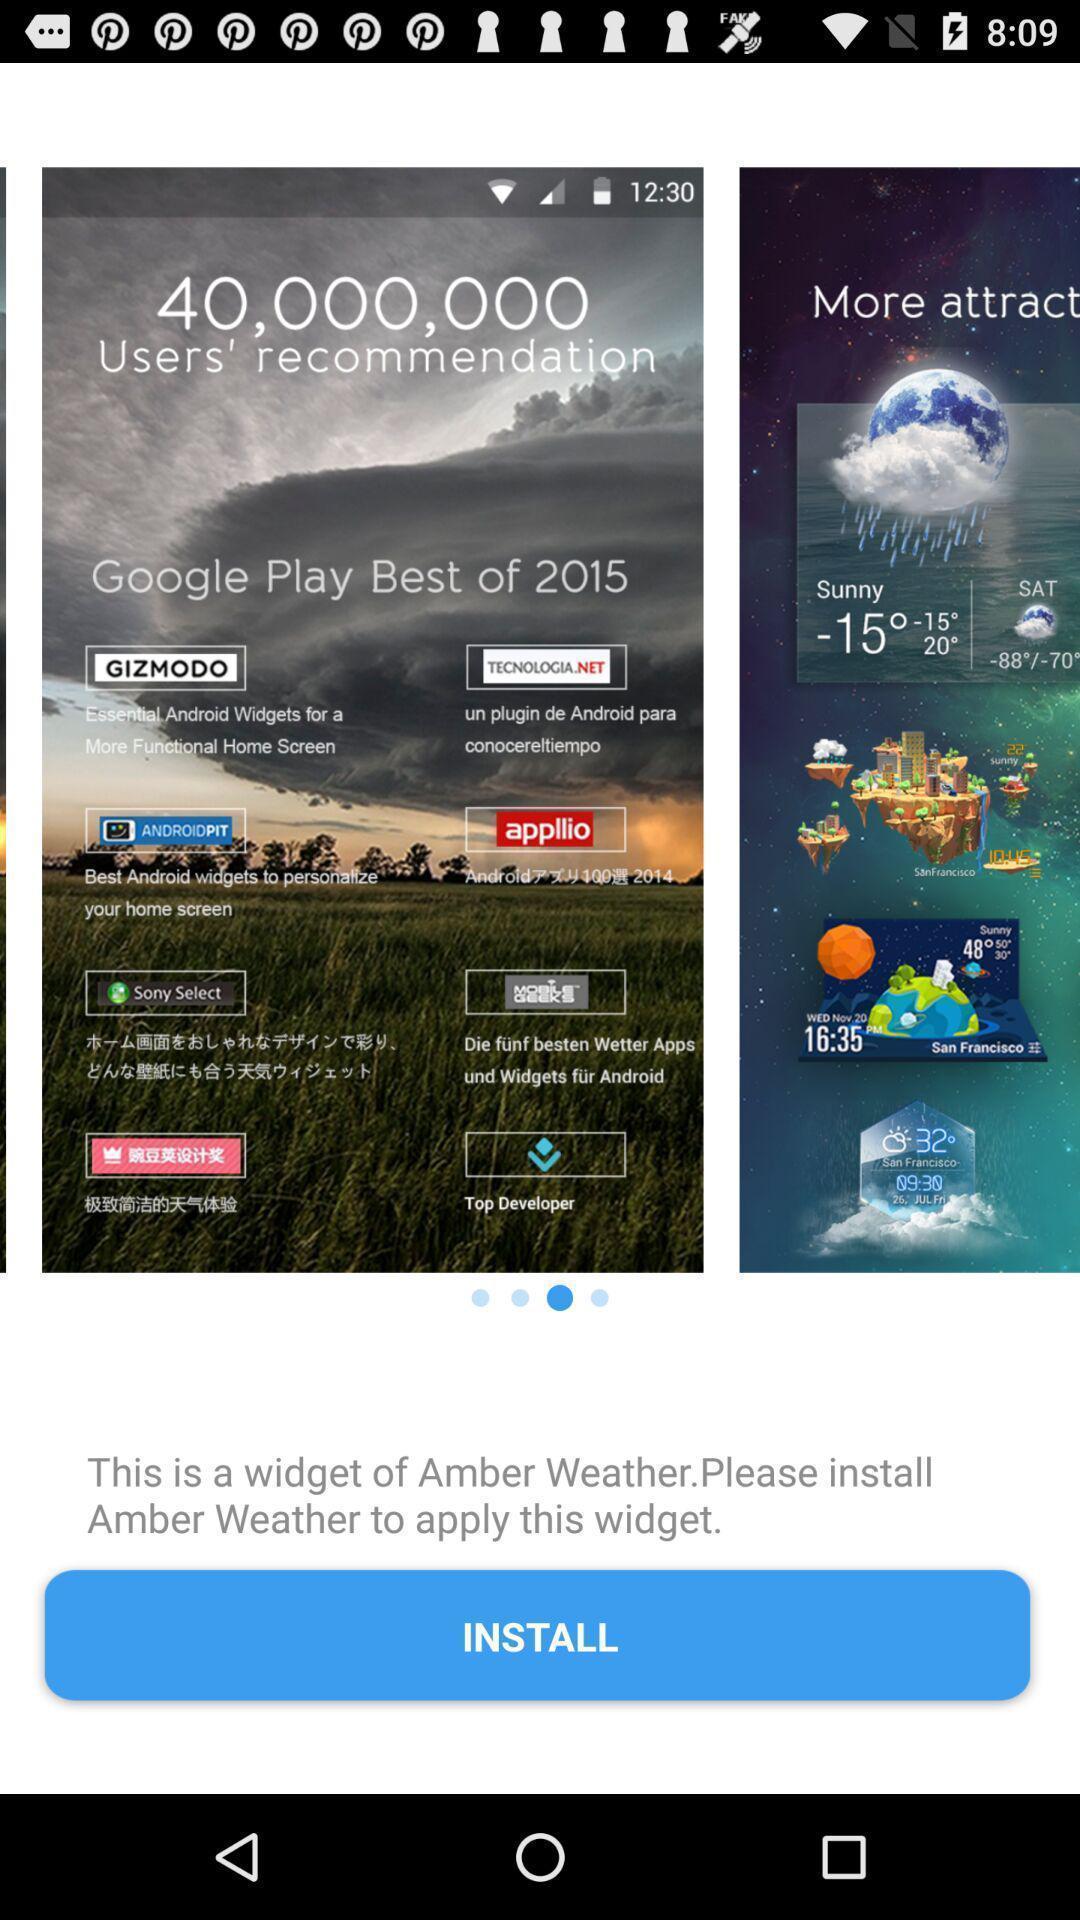Summarize the main components in this picture. Page requesting to install an app. 